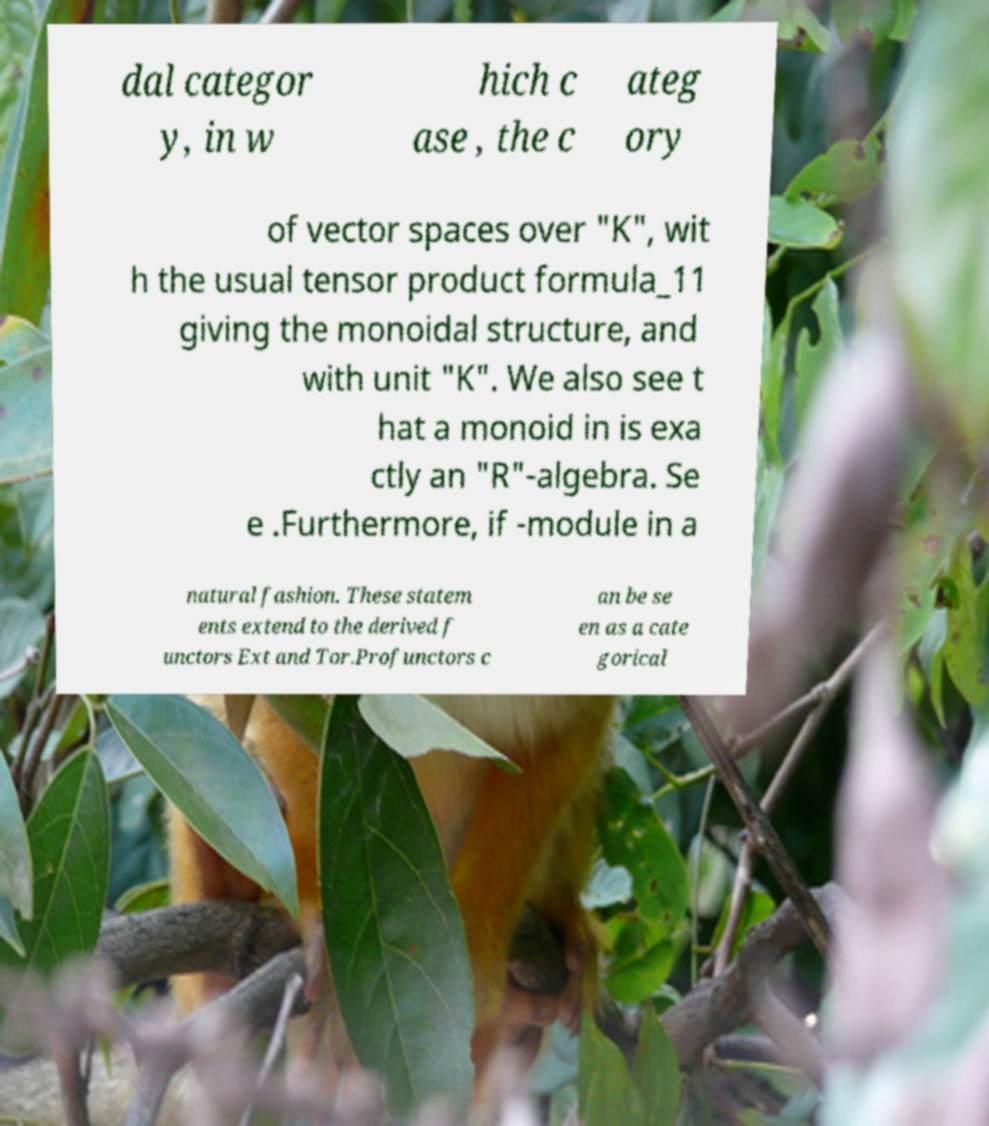There's text embedded in this image that I need extracted. Can you transcribe it verbatim? dal categor y, in w hich c ase , the c ateg ory of vector spaces over "K", wit h the usual tensor product formula_11 giving the monoidal structure, and with unit "K". We also see t hat a monoid in is exa ctly an "R"-algebra. Se e .Furthermore, if -module in a natural fashion. These statem ents extend to the derived f unctors Ext and Tor.Profunctors c an be se en as a cate gorical 